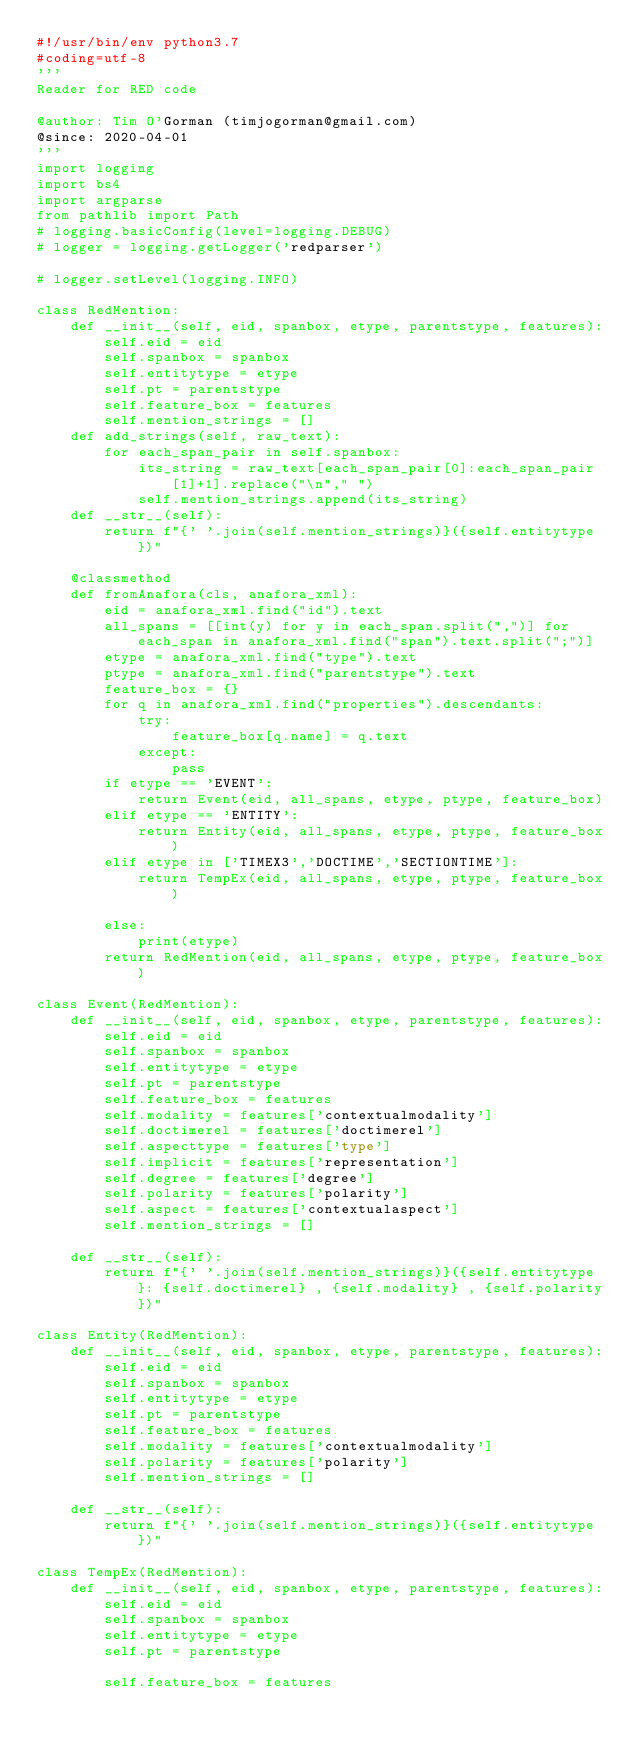<code> <loc_0><loc_0><loc_500><loc_500><_Python_>#!/usr/bin/env python3.7
#coding=utf-8
'''
Reader for RED code

@author: Tim O'Gorman (timjogorman@gmail.com)
@since: 2020-04-01
'''
import logging
import bs4
import argparse
from pathlib import Path
# logging.basicConfig(level=logging.DEBUG)
# logger = logging.getLogger('redparser')

# logger.setLevel(logging.INFO)

class RedMention:
    def __init__(self, eid, spanbox, etype, parentstype, features):
        self.eid = eid
        self.spanbox = spanbox
        self.entitytype = etype
        self.pt = parentstype
        self.feature_box = features
        self.mention_strings = []
    def add_strings(self, raw_text):
        for each_span_pair in self.spanbox:
            its_string = raw_text[each_span_pair[0]:each_span_pair[1]+1].replace("\n"," ")
            self.mention_strings.append(its_string)
    def __str__(self):
        return f"{' '.join(self.mention_strings)}({self.entitytype})"

    @classmethod
    def fromAnafora(cls, anafora_xml):
        eid = anafora_xml.find("id").text
        all_spans = [[int(y) for y in each_span.split(",")] for each_span in anafora_xml.find("span").text.split(";")]
        etype = anafora_xml.find("type").text
        ptype = anafora_xml.find("parentstype").text
        feature_box = {}
        for q in anafora_xml.find("properties").descendants:
            try:
                feature_box[q.name] = q.text
            except:
                pass
        if etype == 'EVENT':
            return Event(eid, all_spans, etype, ptype, feature_box)
        elif etype == 'ENTITY':
            return Entity(eid, all_spans, etype, ptype, feature_box)
        elif etype in ['TIMEX3','DOCTIME','SECTIONTIME']:
            return TempEx(eid, all_spans, etype, ptype, feature_box)
        
        else:
            print(etype)
        return RedMention(eid, all_spans, etype, ptype, feature_box)

class Event(RedMention):
    def __init__(self, eid, spanbox, etype, parentstype, features):
        self.eid = eid
        self.spanbox = spanbox
        self.entitytype = etype
        self.pt = parentstype
        self.feature_box = features
        self.modality = features['contextualmodality']
        self.doctimerel = features['doctimerel']
        self.aspecttype = features['type']
        self.implicit = features['representation']
        self.degree = features['degree']
        self.polarity = features['polarity']
        self.aspect = features['contextualaspect']
        self.mention_strings = []

    def __str__(self):
        return f"{' '.join(self.mention_strings)}({self.entitytype}: {self.doctimerel} , {self.modality} , {self.polarity})"

class Entity(RedMention):
    def __init__(self, eid, spanbox, etype, parentstype, features):
        self.eid = eid
        self.spanbox = spanbox
        self.entitytype = etype
        self.pt = parentstype
        self.feature_box = features
        self.modality = features['contextualmodality']
        self.polarity = features['polarity']
        self.mention_strings = []

    def __str__(self):
        return f"{' '.join(self.mention_strings)}({self.entitytype})"

class TempEx(RedMention):
    def __init__(self, eid, spanbox, etype, parentstype, features):
        self.eid = eid
        self.spanbox = spanbox
        self.entitytype = etype
        self.pt = parentstype

        self.feature_box = features</code> 